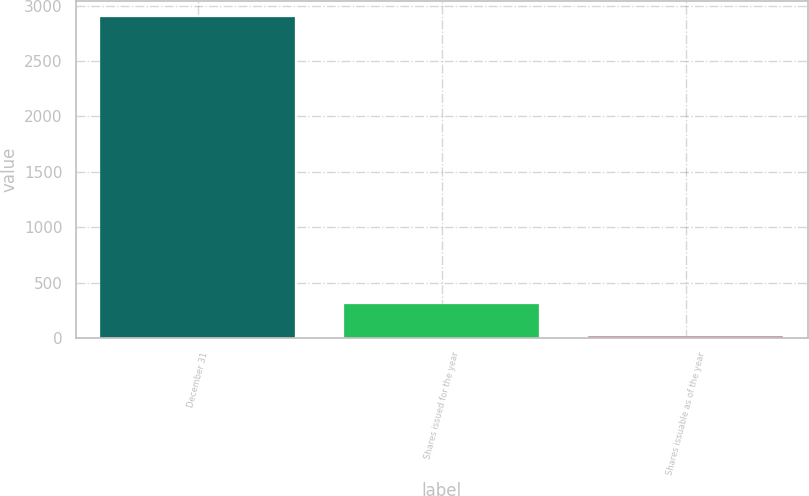Convert chart to OTSL. <chart><loc_0><loc_0><loc_500><loc_500><bar_chart><fcel>December 31<fcel>Shares issued for the year<fcel>Shares issuable as of the year<nl><fcel>2894<fcel>306.5<fcel>19<nl></chart> 